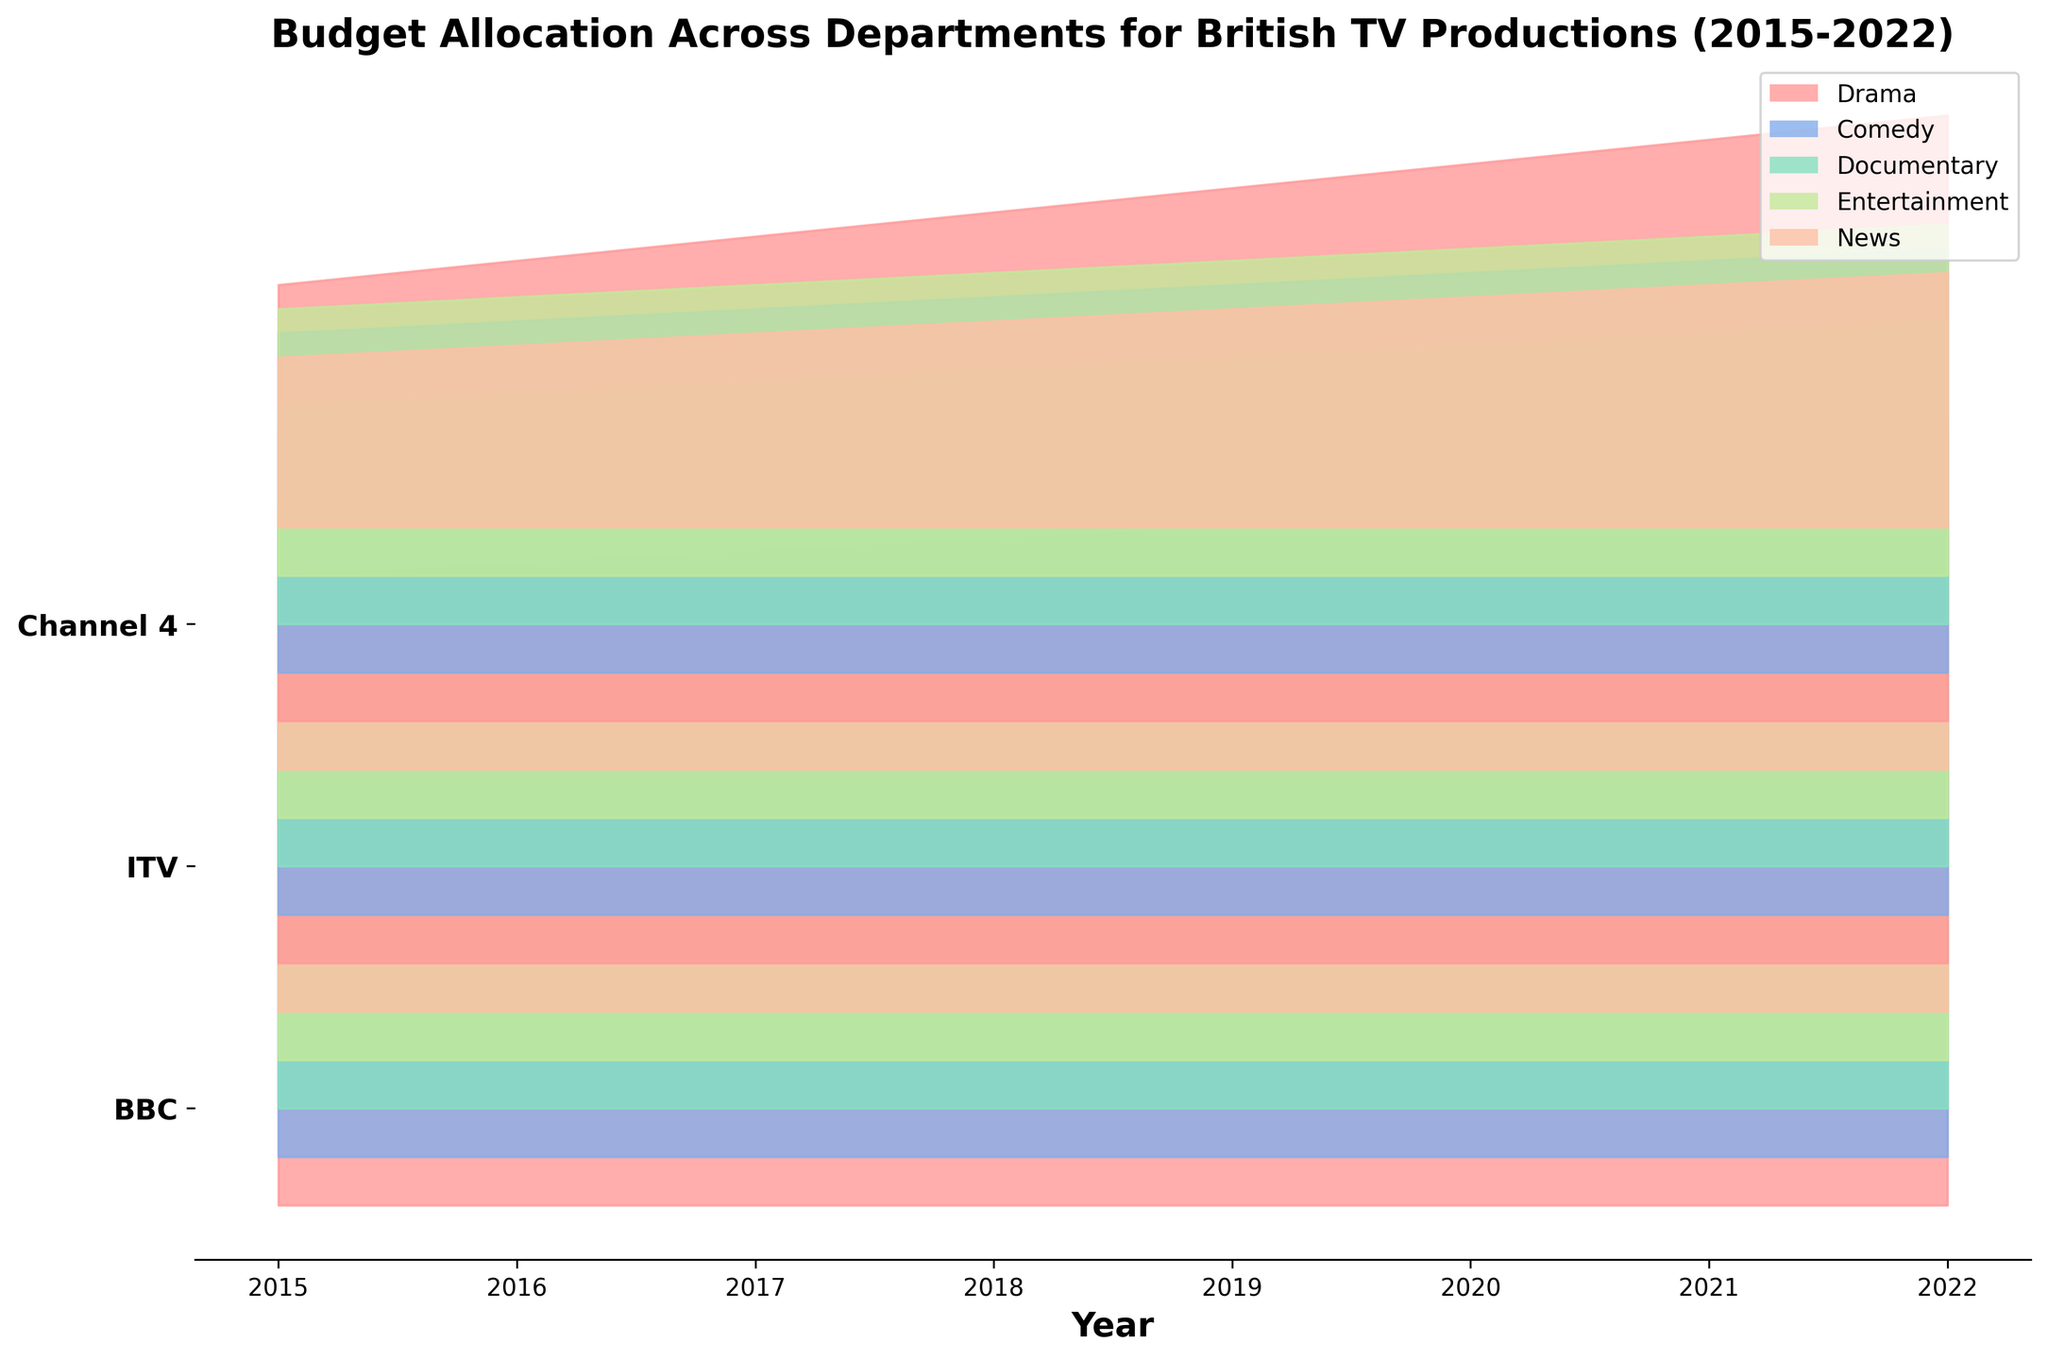What's the title of the plot? The title of the plot is usually displayed at the top and should succinctly describe what the plot represents. In this case, it is "Budget Allocation Across Departments for British TV Productions (2015-2022)."
Answer: Budget Allocation Across Departments for British TV Productions (2015-2022) Which network had the highest budget allocation for Drama in 2019? To answer this, look for the year 2019 on the x-axis and compare the height of the Drama allocations across different networks. For 2019, the BBC's allocation for Drama is higher than ITV and Channel 4.
Answer: BBC Compare the budget allocation trends for Comedy and Entertainment from 2015 to 2018 for the BBC. Which one has a steeper increase? Looking at the filled regions for Comedy and Entertainment from 2015 to 2018 on the plot for BBC, note the increase in their heights. Calculate the difference: Comedy goes from 180 to 195, an increase of 15 units; Entertainment goes from 150 to 165, an increase of 15 units as well.
Answer: Both have the same increase Which category had the most consistent budget allocation across years for Channel 4? Look at the bands for each category across the years for Channel 4. The one that remains the most horizontal and uniform in width will be the most consistent. The "News" category appears the most consistent.
Answer: News How does the budget allocation for Documentaries in 2022 compare across BBC, ITV, and Channel 4? Locate the year 2022 on the x-axis and compare the heights of the Documentaries' budget allocation for each network. BBC's allocation (155) is higher than ITV (135) and Channel 4 (125).
Answer: BBC > ITV > Channel 4 Calculate the average budget allocation for Drama from 2015 to 2022 for Channel 4. Sum the budget allocations for Drama from 2015 to 2022 for Channel 4 (180, 190, 200, 210, 220, 230, 240, 250) which totals 1720. Divide this by the number of years (8) to find the average: 1720 / 8 = 215.
Answer: 215 Which network saw the biggest increase in budget allocation for News from 2015 to 2022? Compare the starting and ending heights of the News category for each network from 2015 to 2022. BBC went from 100 to 135 (increase of 35), ITV from 80 to 115 (increase of 35), and Channel 4 from 70 to 105 (increase of 35). They all increased equally.
Answer: All networks had the same increase Are there any categories where ITV outspends the BBC in any given year? Examine the heights of the filled regions for each category and each year. ITV consistently has lower allocations compared to the BBC across all categories.
Answer: No Does any network show a budget decline in any category from 2015 to 2022? Scan the plot for any downward trends in the filled regions for each category and network. All networks show an increase or stable budget allocations in all categories over the years.
Answer: No 